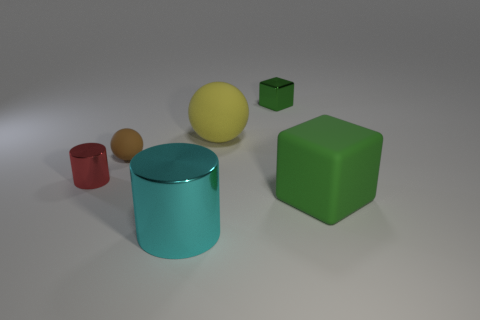How many other objects are the same shape as the big yellow object?
Offer a very short reply. 1. Is there any other thing that has the same material as the cyan object?
Ensure brevity in your answer.  Yes. There is a big matte object that is behind the shiny thing that is to the left of the object in front of the matte cube; what color is it?
Offer a terse response. Yellow. There is a large thing that is on the right side of the tiny shiny block; does it have the same shape as the red thing?
Provide a short and direct response. No. How many big cyan cylinders are there?
Keep it short and to the point. 1. How many metal objects are the same size as the yellow sphere?
Give a very brief answer. 1. What material is the big green block?
Your answer should be compact. Rubber. Is the color of the matte block the same as the metallic object that is right of the big cyan shiny object?
Ensure brevity in your answer.  Yes. Is there any other thing that has the same size as the green metallic thing?
Your answer should be very brief. Yes. There is a object that is both in front of the green metallic thing and to the right of the yellow rubber ball; what is its size?
Keep it short and to the point. Large. 